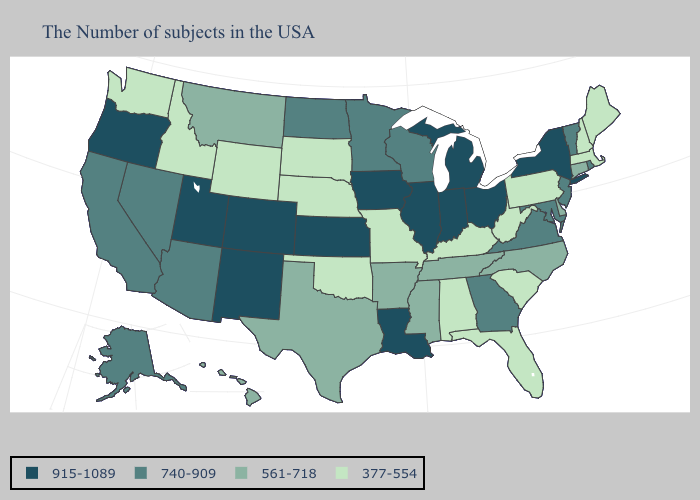Which states have the lowest value in the West?
Keep it brief. Wyoming, Idaho, Washington. Name the states that have a value in the range 915-1089?
Keep it brief. New York, Ohio, Michigan, Indiana, Illinois, Louisiana, Iowa, Kansas, Colorado, New Mexico, Utah, Oregon. Name the states that have a value in the range 915-1089?
Concise answer only. New York, Ohio, Michigan, Indiana, Illinois, Louisiana, Iowa, Kansas, Colorado, New Mexico, Utah, Oregon. Among the states that border Colorado , which have the lowest value?
Concise answer only. Nebraska, Oklahoma, Wyoming. Name the states that have a value in the range 915-1089?
Answer briefly. New York, Ohio, Michigan, Indiana, Illinois, Louisiana, Iowa, Kansas, Colorado, New Mexico, Utah, Oregon. Does the first symbol in the legend represent the smallest category?
Be succinct. No. What is the value of Georgia?
Quick response, please. 740-909. Does Florida have a lower value than New Hampshire?
Give a very brief answer. No. Name the states that have a value in the range 915-1089?
Concise answer only. New York, Ohio, Michigan, Indiana, Illinois, Louisiana, Iowa, Kansas, Colorado, New Mexico, Utah, Oregon. Name the states that have a value in the range 561-718?
Concise answer only. Connecticut, Delaware, North Carolina, Tennessee, Mississippi, Arkansas, Texas, Montana, Hawaii. What is the value of Mississippi?
Answer briefly. 561-718. What is the lowest value in the USA?
Give a very brief answer. 377-554. Name the states that have a value in the range 740-909?
Keep it brief. Rhode Island, Vermont, New Jersey, Maryland, Virginia, Georgia, Wisconsin, Minnesota, North Dakota, Arizona, Nevada, California, Alaska. Does Michigan have the highest value in the USA?
Answer briefly. Yes. Which states hav the highest value in the South?
Give a very brief answer. Louisiana. 